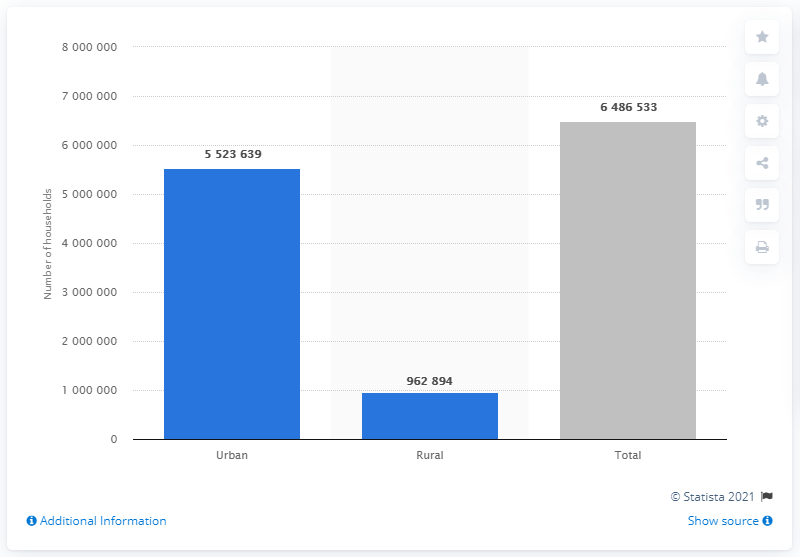Identify some key points in this picture. In Chile, approximately 6.5 million households reside, and of those, a significant portion, approximately 55.2 million, are situated in urban areas. 